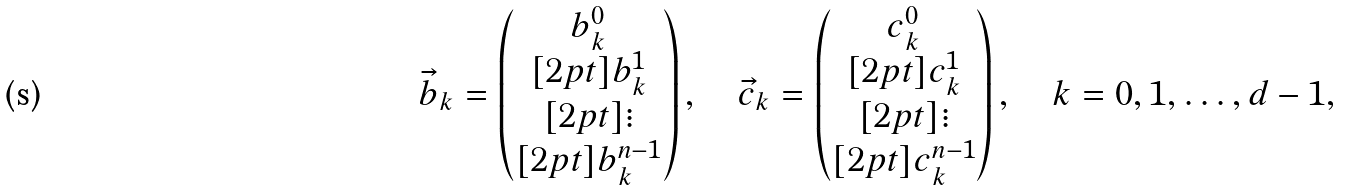Convert formula to latex. <formula><loc_0><loc_0><loc_500><loc_500>\vec { b } _ { k } = \begin{pmatrix} b _ { k } ^ { 0 } \\ [ 2 p t ] b _ { k } ^ { 1 } \\ [ 2 p t ] \vdots \\ [ 2 p t ] b _ { k } ^ { n - 1 } \end{pmatrix} , \quad \vec { c } _ { k } = \begin{pmatrix} c _ { k } ^ { 0 } \\ [ 2 p t ] c _ { k } ^ { 1 } \\ [ 2 p t ] \vdots \\ [ 2 p t ] c _ { k } ^ { n - 1 } \end{pmatrix} , \quad k = 0 , 1 , \dots , d - 1 ,</formula> 